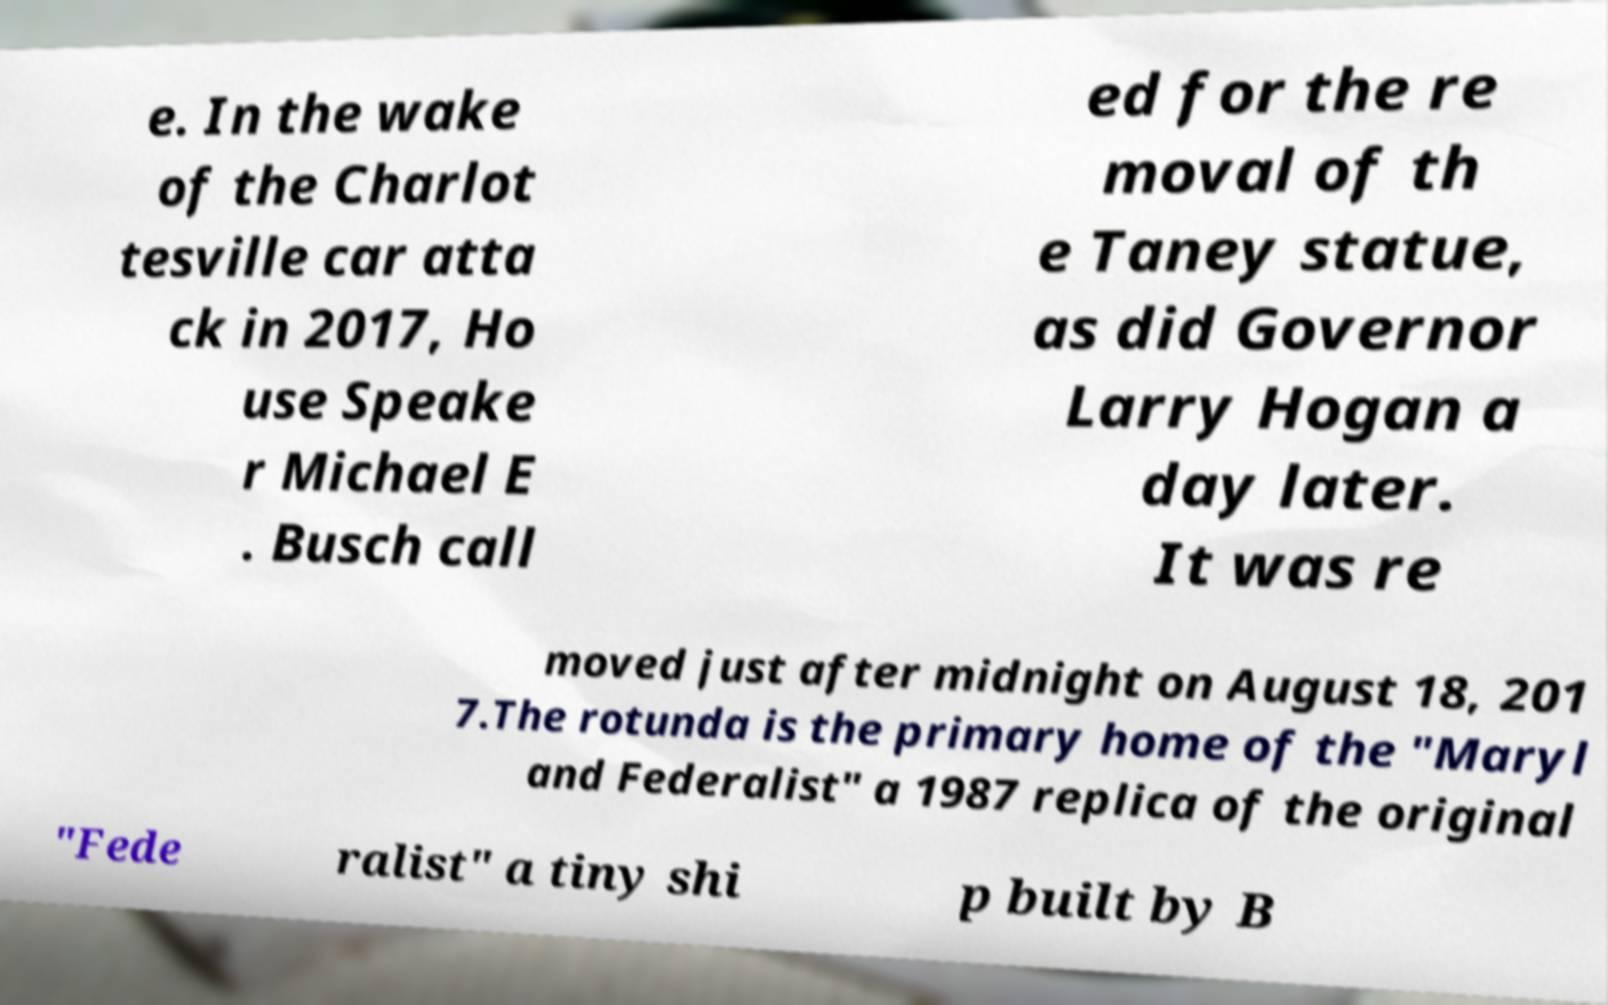What messages or text are displayed in this image? I need them in a readable, typed format. e. In the wake of the Charlot tesville car atta ck in 2017, Ho use Speake r Michael E . Busch call ed for the re moval of th e Taney statue, as did Governor Larry Hogan a day later. It was re moved just after midnight on August 18, 201 7.The rotunda is the primary home of the "Maryl and Federalist" a 1987 replica of the original "Fede ralist" a tiny shi p built by B 